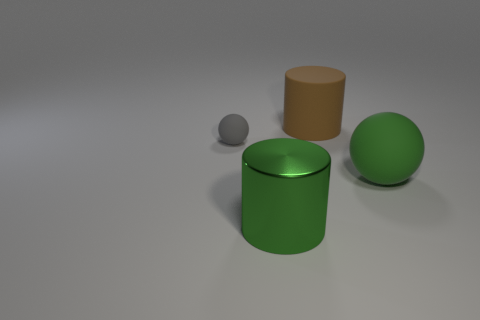Do the metal thing and the big ball have the same color? Yes, the metallic cylinder and the larger sphere both exhibit a shade of green. However, the reflective surface of the cylinder may cause variations in hue under different lighting conditions. 